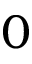Convert formula to latex. <formula><loc_0><loc_0><loc_500><loc_500>0</formula> 